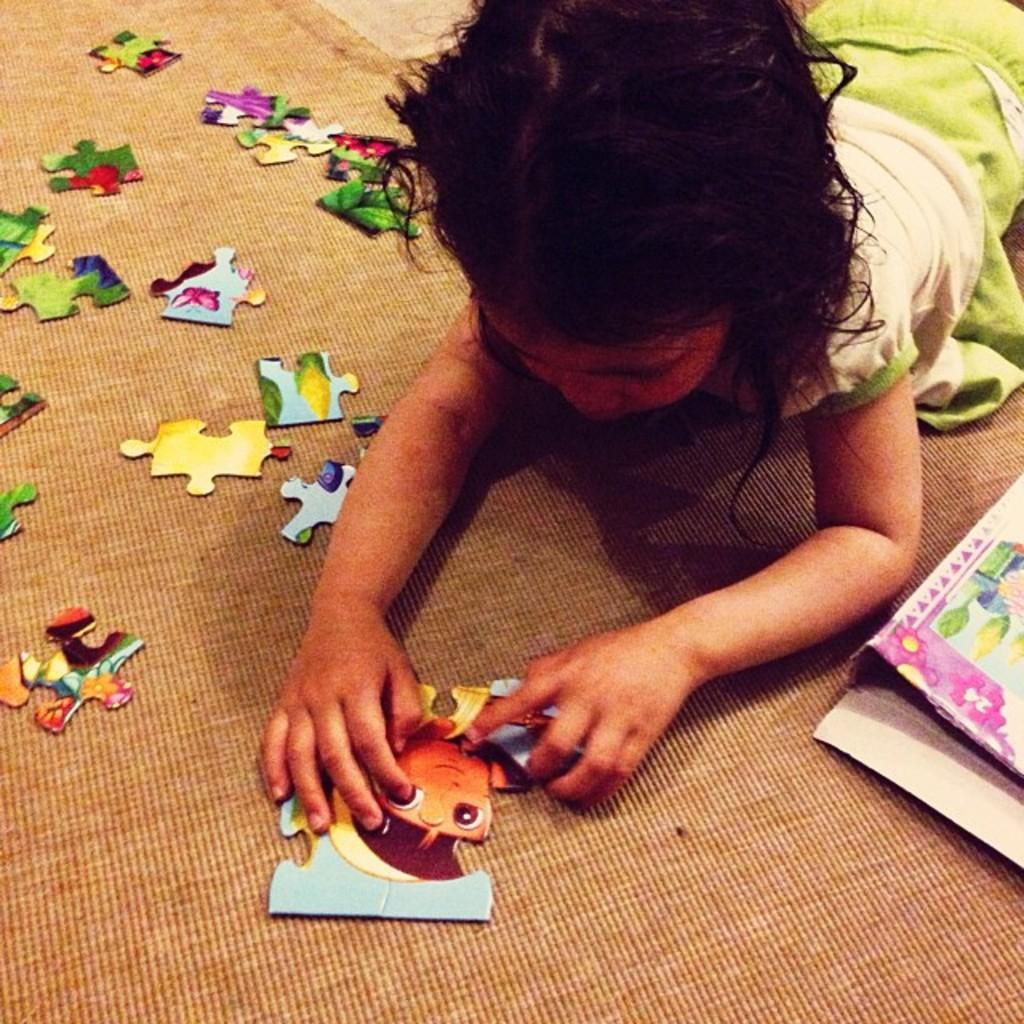What is the main subject of the image? There is a child in the image. What is the child doing in the image? The child is playing a puzzle game. Where is the puzzle game located in the image? The puzzle game is on the floor. What is the child's belief about the importance of adjusting the puzzle pieces in the image? There is no information about the child's beliefs or the importance of adjusting the puzzle pieces in the image. 